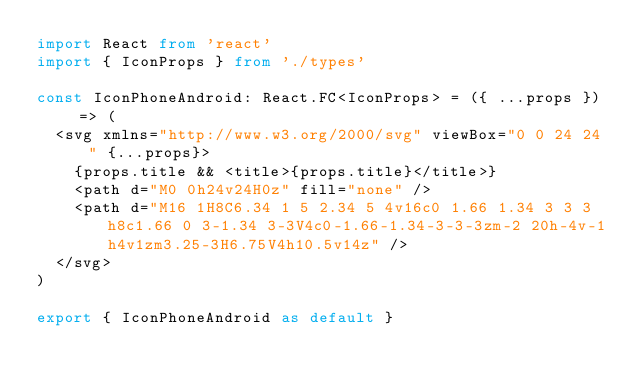Convert code to text. <code><loc_0><loc_0><loc_500><loc_500><_TypeScript_>import React from 'react'
import { IconProps } from './types'

const IconPhoneAndroid: React.FC<IconProps> = ({ ...props }) => (
  <svg xmlns="http://www.w3.org/2000/svg" viewBox="0 0 24 24" {...props}>
    {props.title && <title>{props.title}</title>}
    <path d="M0 0h24v24H0z" fill="none" />
    <path d="M16 1H8C6.34 1 5 2.34 5 4v16c0 1.66 1.34 3 3 3h8c1.66 0 3-1.34 3-3V4c0-1.66-1.34-3-3-3zm-2 20h-4v-1h4v1zm3.25-3H6.75V4h10.5v14z" />
  </svg>
)

export { IconPhoneAndroid as default }
</code> 